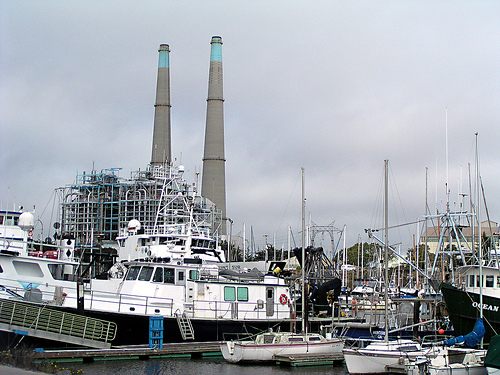<image>
Can you confirm if the chimney is on the boat? No. The chimney is not positioned on the boat. They may be near each other, but the chimney is not supported by or resting on top of the boat. 